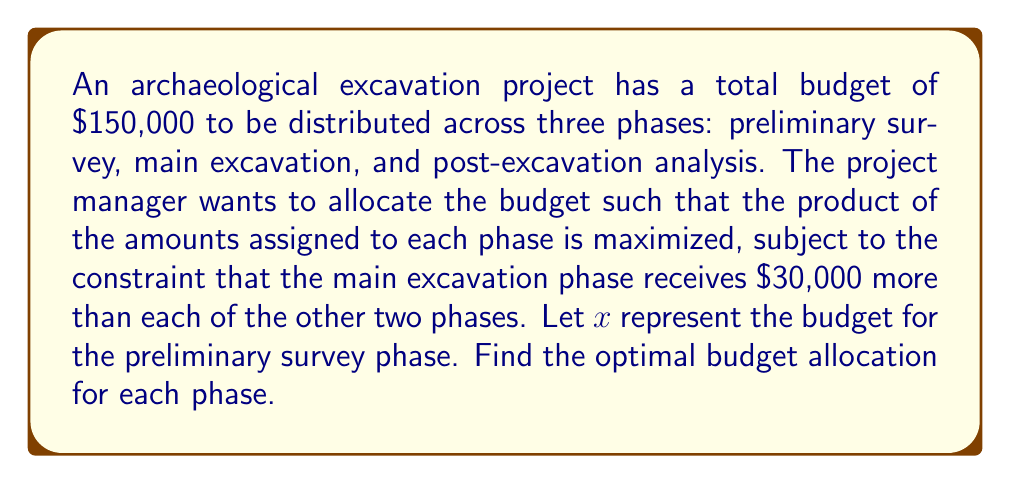Help me with this question. 1) Let's define our variables:
   x = budget for preliminary survey
   x + 30000 = budget for main excavation
   x = budget for post-excavation analysis

2) We know the total budget is $150,000, so we can write:
   $x + (x + 30000) + x = 150000$

3) Simplify the equation:
   $3x + 30000 = 150000$

4) Solve for x:
   $3x = 120000$
   $x = 40000$

5) Now we know:
   Preliminary survey: $40000
   Main excavation: $40000 + $30000 = $70000
   Post-excavation analysis: $40000

6) To verify, let's check if these values maximize the product of the amounts:
   Let f(x) be the product function:
   $f(x) = x(x+30000)x = x^2(x+30000)$

7) To find the maximum, we differentiate f(x) and set it to zero:
   $f'(x) = 2x(x+30000) + x^2 = 3x^2 + 60000x$
   $0 = 3x^2 + 60000x$
   $0 = 3x(x + 20000)$

8) Solving this equation gives us x = 0 or x = -20000. Since x cannot be negative in this context, the only critical point is x = 0, which is a minimum.

9) The maximum must occur at one of the endpoints of our domain. Given our constraint of a total budget of $150,000, x = 40000 is indeed the optimal solution.
Answer: Preliminary survey: $40,000; Main excavation: $70,000; Post-excavation analysis: $40,000 